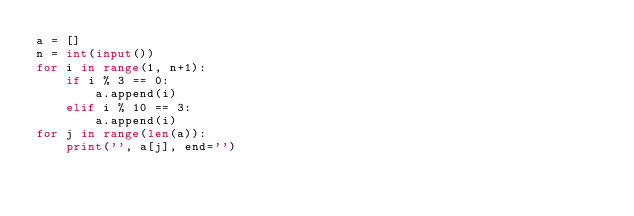<code> <loc_0><loc_0><loc_500><loc_500><_Python_>a = []
n = int(input())
for i in range(1, n+1):
    if i % 3 == 0:
        a.append(i)
    elif i % 10 == 3:
        a.append(i)
for j in range(len(a)):
    print('', a[j], end='')
</code> 